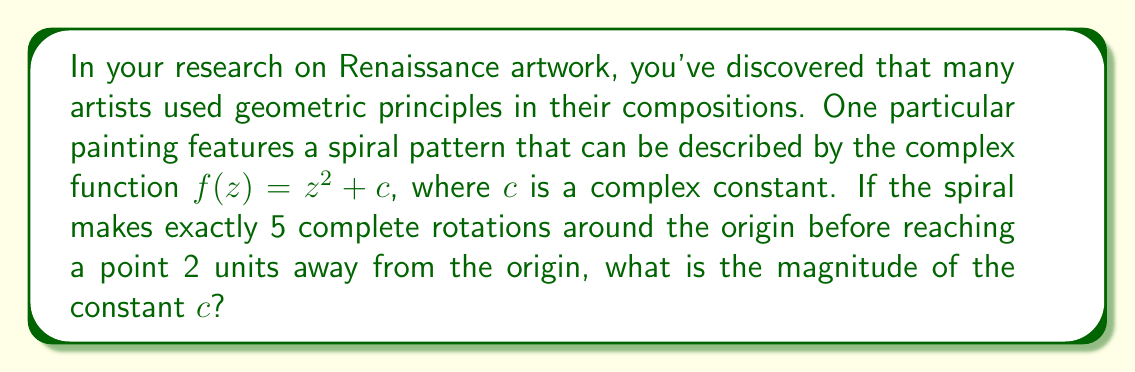Solve this math problem. To solve this problem, we need to understand how the complex function $f(z) = z^2 + c$ behaves and relate it to the spiral pattern in the artwork.

1) The function $f(z) = z^2 + c$ is known as the quadratic map, which is fundamental in the study of fractal geometry and complex dynamics.

2) When this function is iterated (applied repeatedly), it can produce spiral patterns. The number of rotations and the rate of expansion depend on the value of $c$.

3) For a spiral that makes exactly 5 rotations, we can use the polar form of complex numbers. Let's say the spiral starts very close to the origin and ends at a point 2 units away.

4) In polar form, we can write this as:

   $z_5 = 2e^{10\pi i}$

   The $10\pi$ in the exponent comes from 5 full rotations (each rotation is $2\pi$).

5) Now, we need to work backwards to find $c$. Let's call the starting point $z_0$. Then:

   $z_1 = z_0^2 + c$
   $z_2 = z_1^2 + c = (z_0^2 + c)^2 + c$
   $z_3 = z_2^2 + c = ((z_0^2 + c)^2 + c)^2 + c$
   ...and so on.

6) For small $|c|$ and $|z_0|$, we can approximate this process as:

   $z_n \approx c^{2^n-1}$

7) Using this approximation for $n=5$:

   $2e^{10\pi i} \approx c^{31}$

8) Taking the 31st root of both sides:

   $\sqrt[31]{2}e^{\frac{10\pi i}{31}} \approx c$

9) The magnitude of $c$ is therefore approximately $\sqrt[31]{2} \approx 1.0224$

This approximation becomes more accurate as $|c|$ gets smaller and the number of iterations increases.
Answer: The magnitude of the constant $c$ is approximately 1.0224. 